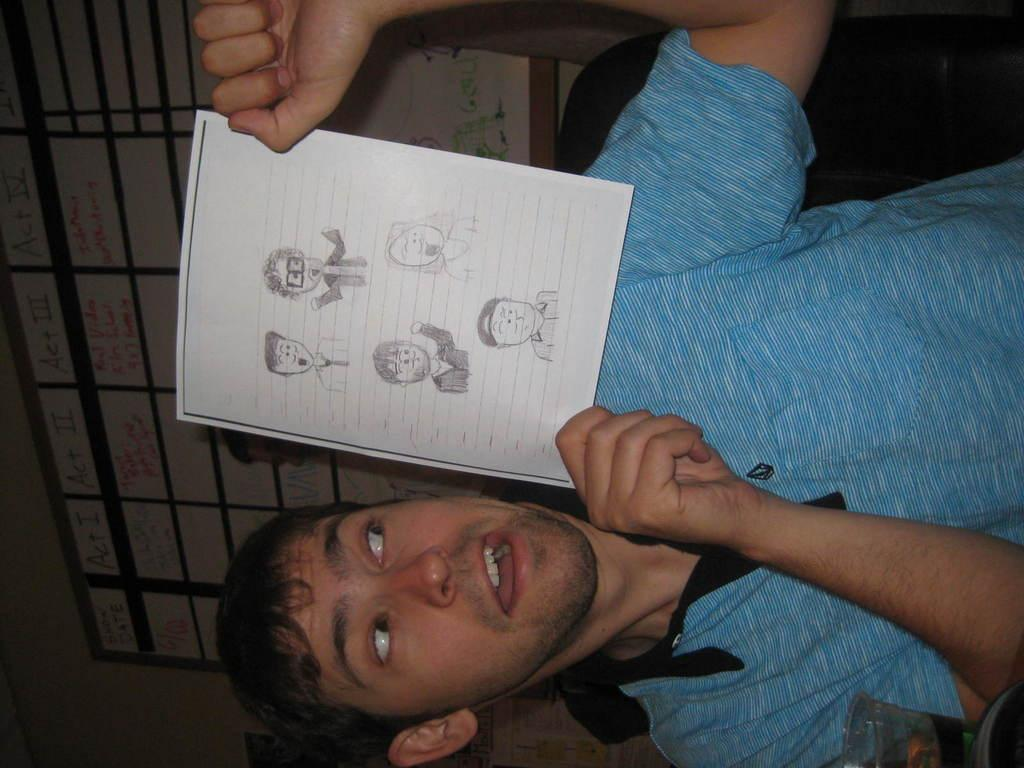What is the person in the image doing? The person is holding a paper. Can you describe the person's attire in the image? The person is wearing a blue and black color dress. What is attached to the wall in the image? There is a board attached to the wall in the image. What type of oil is being used to fuel the war in the image? There is no war or oil present in the image; it features a person holding a paper and wearing a blue and black color dress, with a board attached to the wall. 